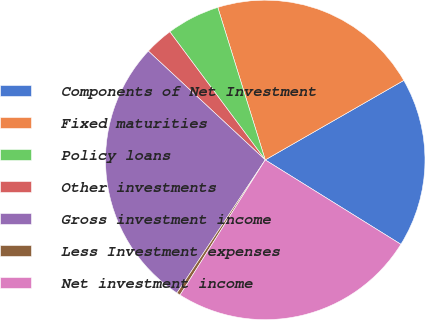Convert chart to OTSL. <chart><loc_0><loc_0><loc_500><loc_500><pie_chart><fcel>Components of Net Investment<fcel>Fixed maturities<fcel>Policy loans<fcel>Other investments<fcel>Gross investment income<fcel>Less Investment expenses<fcel>Net investment income<nl><fcel>17.15%<fcel>21.51%<fcel>5.39%<fcel>2.88%<fcel>27.61%<fcel>0.37%<fcel>25.1%<nl></chart> 